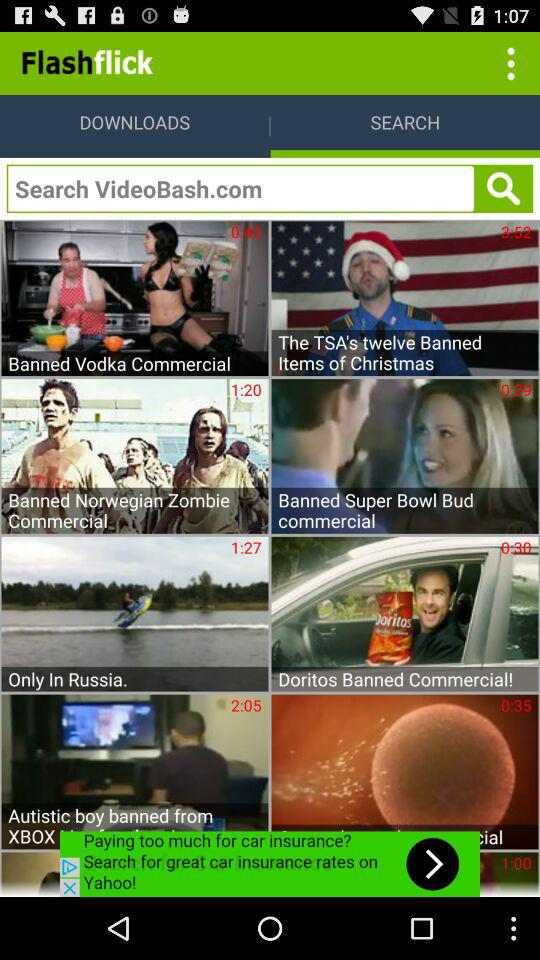How many videos are in the 'Banned' category?
Answer the question using a single word or phrase. 6 